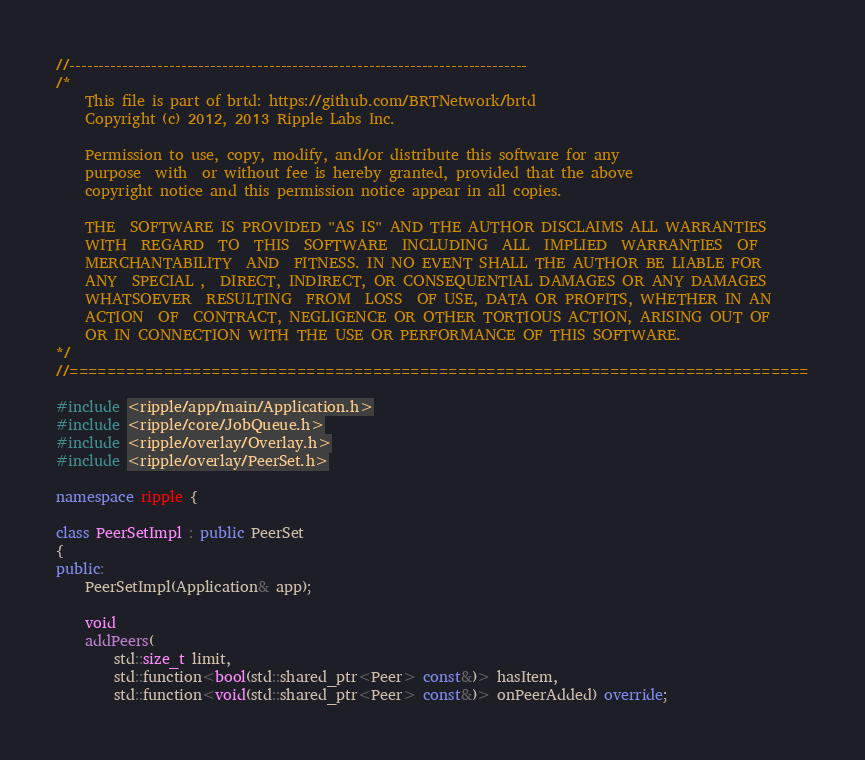Convert code to text. <code><loc_0><loc_0><loc_500><loc_500><_C++_>//------------------------------------------------------------------------------
/*
    This file is part of brtd: https://github.com/BRTNetwork/brtd
    Copyright (c) 2012, 2013 Ripple Labs Inc.

    Permission to use, copy, modify, and/or distribute this software for any
    purpose  with  or without fee is hereby granted, provided that the above
    copyright notice and this permission notice appear in all copies.

    THE  SOFTWARE IS PROVIDED "AS IS" AND THE AUTHOR DISCLAIMS ALL WARRANTIES
    WITH  REGARD  TO  THIS  SOFTWARE  INCLUDING  ALL  IMPLIED  WARRANTIES  OF
    MERCHANTABILITY  AND  FITNESS. IN NO EVENT SHALL THE AUTHOR BE LIABLE FOR
    ANY  SPECIAL ,  DIRECT, INDIRECT, OR CONSEQUENTIAL DAMAGES OR ANY DAMAGES
    WHATSOEVER  RESULTING  FROM  LOSS  OF USE, DATA OR PROFITS, WHETHER IN AN
    ACTION  OF  CONTRACT, NEGLIGENCE OR OTHER TORTIOUS ACTION, ARISING OUT OF
    OR IN CONNECTION WITH THE USE OR PERFORMANCE OF THIS SOFTWARE.
*/
//==============================================================================

#include <ripple/app/main/Application.h>
#include <ripple/core/JobQueue.h>
#include <ripple/overlay/Overlay.h>
#include <ripple/overlay/PeerSet.h>

namespace ripple {

class PeerSetImpl : public PeerSet
{
public:
    PeerSetImpl(Application& app);

    void
    addPeers(
        std::size_t limit,
        std::function<bool(std::shared_ptr<Peer> const&)> hasItem,
        std::function<void(std::shared_ptr<Peer> const&)> onPeerAdded) override;
</code> 